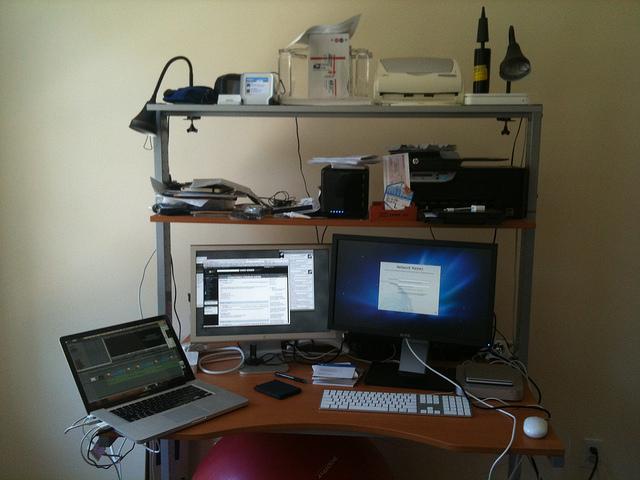Are all of these monitors on?
Quick response, please. Yes. Is the laptop about to fall on the ground?
Write a very short answer. No. Is the laptop computer a Mac?
Short answer required. Yes. What color is the chair?
Give a very brief answer. Red. How many computers?
Concise answer only. 3. Are both computers the same color?
Short answer required. No. What color is the mouse?
Be succinct. White. Is the desk lamp turned on?
Quick response, please. No. Is one of the computers Apple?
Give a very brief answer. Yes. 